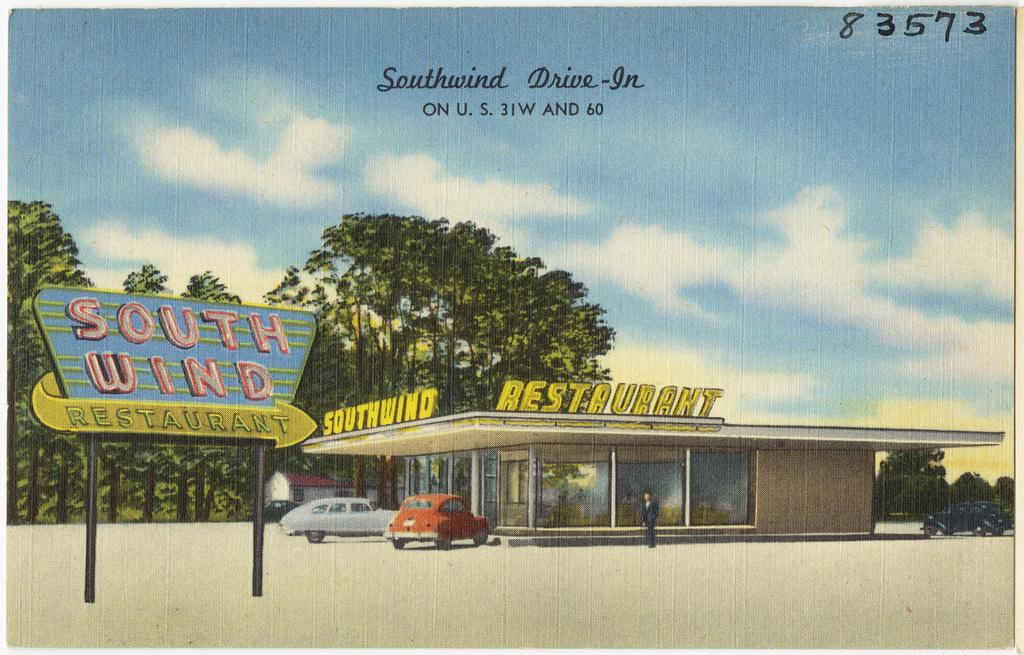What is the main object in the image? There is a board in the image. What else can be seen in the image besides the board? There are vehicles, a person on the road, and a restaurant, trees, and a house in the background. Can you describe the text visible in the background? There is text visible in the background of the image, but its content is not clear from the provided facts. What is visible in the sky in the image? The sky is visible in the background of the image. How can you tell that the image is an edited photo? The image appears to be an edited photo, as stated in the provided facts. What is the person's desire for the territory in the image? There is no information about the person's desires or the territory in the image, as these topics are not mentioned in the provided facts. 